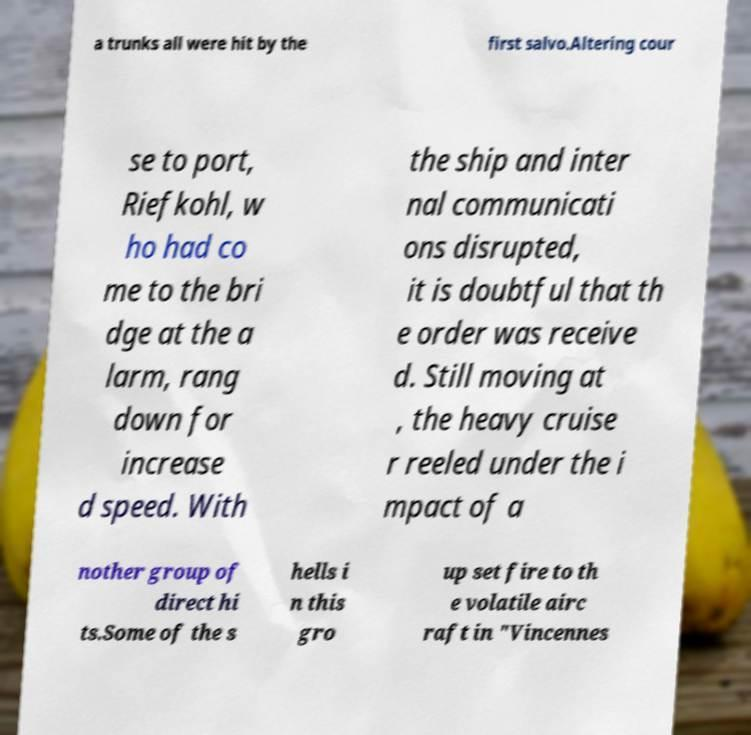Could you assist in decoding the text presented in this image and type it out clearly? a trunks all were hit by the first salvo.Altering cour se to port, Riefkohl, w ho had co me to the bri dge at the a larm, rang down for increase d speed. With the ship and inter nal communicati ons disrupted, it is doubtful that th e order was receive d. Still moving at , the heavy cruise r reeled under the i mpact of a nother group of direct hi ts.Some of the s hells i n this gro up set fire to th e volatile airc raft in "Vincennes 